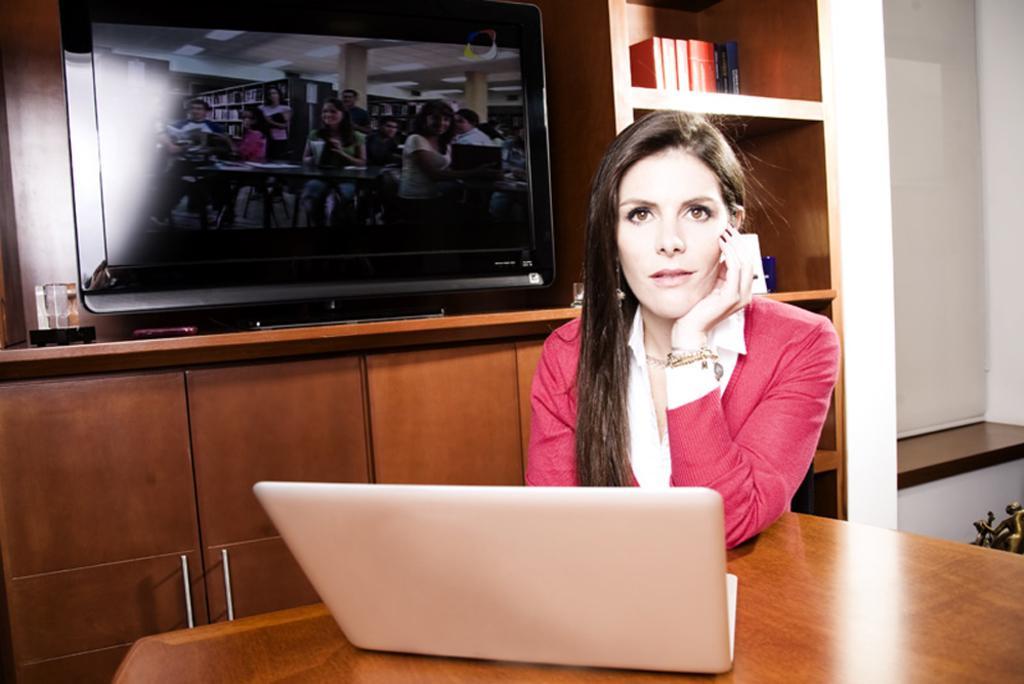In one or two sentences, can you explain what this image depicts? In this image, there is a lady who is sitting on the chair by resting her hands on the table in front of the laptop, there is a television at the left side of the image which is placed on the shelf, there are some books in the shelf at the right side of the image. 